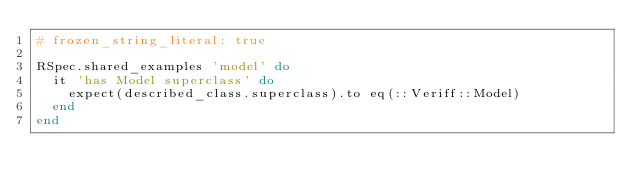<code> <loc_0><loc_0><loc_500><loc_500><_Ruby_># frozen_string_literal: true

RSpec.shared_examples 'model' do
  it 'has Model superclass' do
    expect(described_class.superclass).to eq(::Veriff::Model)
  end
end
</code> 